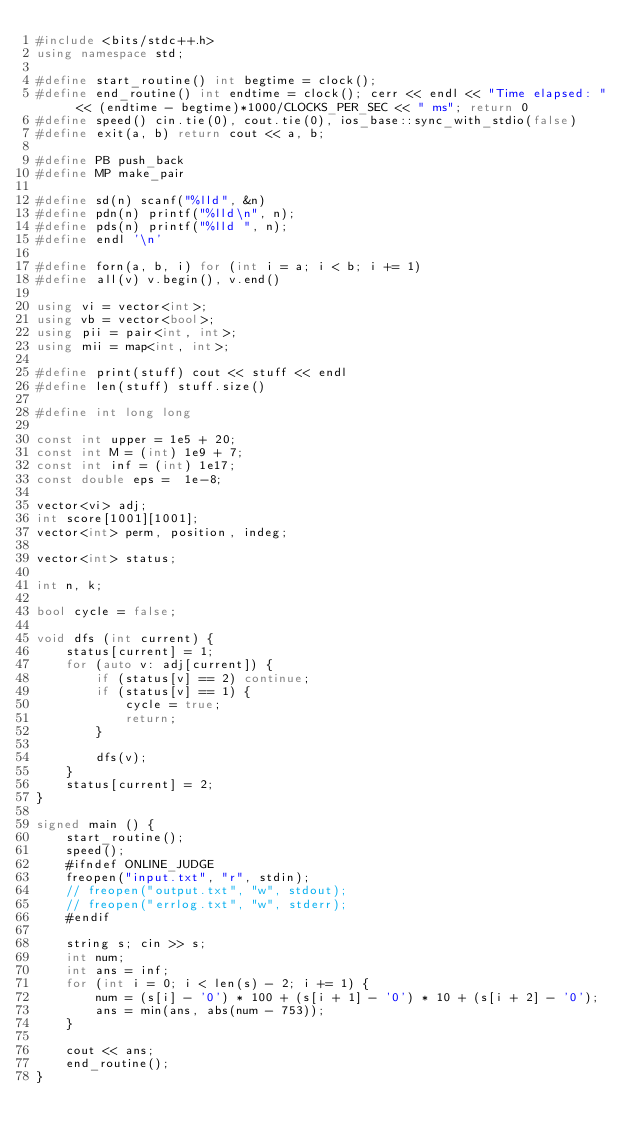<code> <loc_0><loc_0><loc_500><loc_500><_C++_>#include <bits/stdc++.h>
using namespace std;

#define start_routine() int begtime = clock();
#define end_routine() int endtime = clock(); cerr << endl << "Time elapsed: " << (endtime - begtime)*1000/CLOCKS_PER_SEC << " ms"; return 0
#define speed() cin.tie(0), cout.tie(0), ios_base::sync_with_stdio(false)
#define exit(a, b) return cout << a, b;

#define PB push_back
#define MP make_pair

#define sd(n) scanf("%lld", &n)
#define pdn(n) printf("%lld\n", n);
#define pds(n) printf("%lld ", n);
#define endl '\n'

#define forn(a, b, i) for (int i = a; i < b; i += 1)
#define all(v) v.begin(), v.end() 

using vi = vector<int>;
using vb = vector<bool>;
using pii = pair<int, int>;
using mii = map<int, int>;

#define print(stuff) cout << stuff << endl
#define len(stuff) stuff.size()

#define int long long

const int upper = 1e5 + 20;
const int M = (int) 1e9 + 7;
const int inf = (int) 1e17;
const double eps =  1e-8;

vector<vi> adj;
int score[1001][1001];
vector<int> perm, position, indeg;

vector<int> status;

int n, k;

bool cycle = false;

void dfs (int current) {
	status[current] = 1;
	for (auto v: adj[current]) {
		if (status[v] == 2) continue;
		if (status[v] == 1) {
			cycle = true;
			return;
		}

		dfs(v);
	}
	status[current] = 2;
}

signed main () {
	start_routine();
	speed();
	#ifndef ONLINE_JUDGE
	freopen("input.txt", "r", stdin);	
	// freopen("output.txt", "w", stdout);
	// freopen("errlog.txt", "w", stderr);
	#endif		
	
	string s; cin >> s;
	int num;
	int ans = inf;
	for (int i = 0; i < len(s) - 2; i += 1) {
		num = (s[i] - '0') * 100 + (s[i + 1] - '0') * 10 + (s[i + 2] - '0');
		ans = min(ans, abs(num - 753));
	}	

	cout << ans;
 	end_routine();	
}</code> 